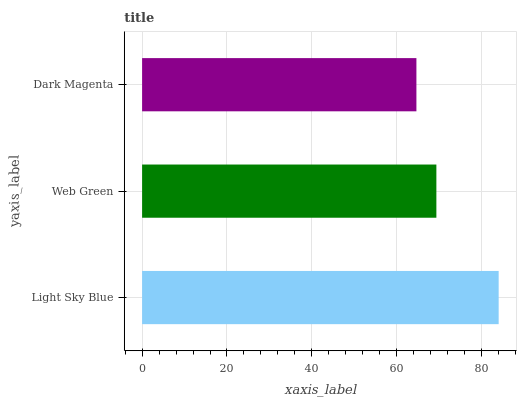Is Dark Magenta the minimum?
Answer yes or no. Yes. Is Light Sky Blue the maximum?
Answer yes or no. Yes. Is Web Green the minimum?
Answer yes or no. No. Is Web Green the maximum?
Answer yes or no. No. Is Light Sky Blue greater than Web Green?
Answer yes or no. Yes. Is Web Green less than Light Sky Blue?
Answer yes or no. Yes. Is Web Green greater than Light Sky Blue?
Answer yes or no. No. Is Light Sky Blue less than Web Green?
Answer yes or no. No. Is Web Green the high median?
Answer yes or no. Yes. Is Web Green the low median?
Answer yes or no. Yes. Is Dark Magenta the high median?
Answer yes or no. No. Is Dark Magenta the low median?
Answer yes or no. No. 